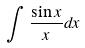Convert formula to latex. <formula><loc_0><loc_0><loc_500><loc_500>\int \frac { \sin x } { x } d x</formula> 